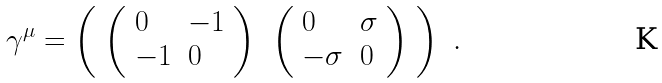Convert formula to latex. <formula><loc_0><loc_0><loc_500><loc_500>\gamma ^ { \mu } = \left ( \begin{array} { l l } \left ( \begin{array} { l l } 0 & - 1 \\ - 1 & 0 \end{array} \right ) & \left ( \begin{array} { l l } 0 & \sigma \\ - \sigma & 0 \end{array} \right ) \end{array} \right ) \ .</formula> 